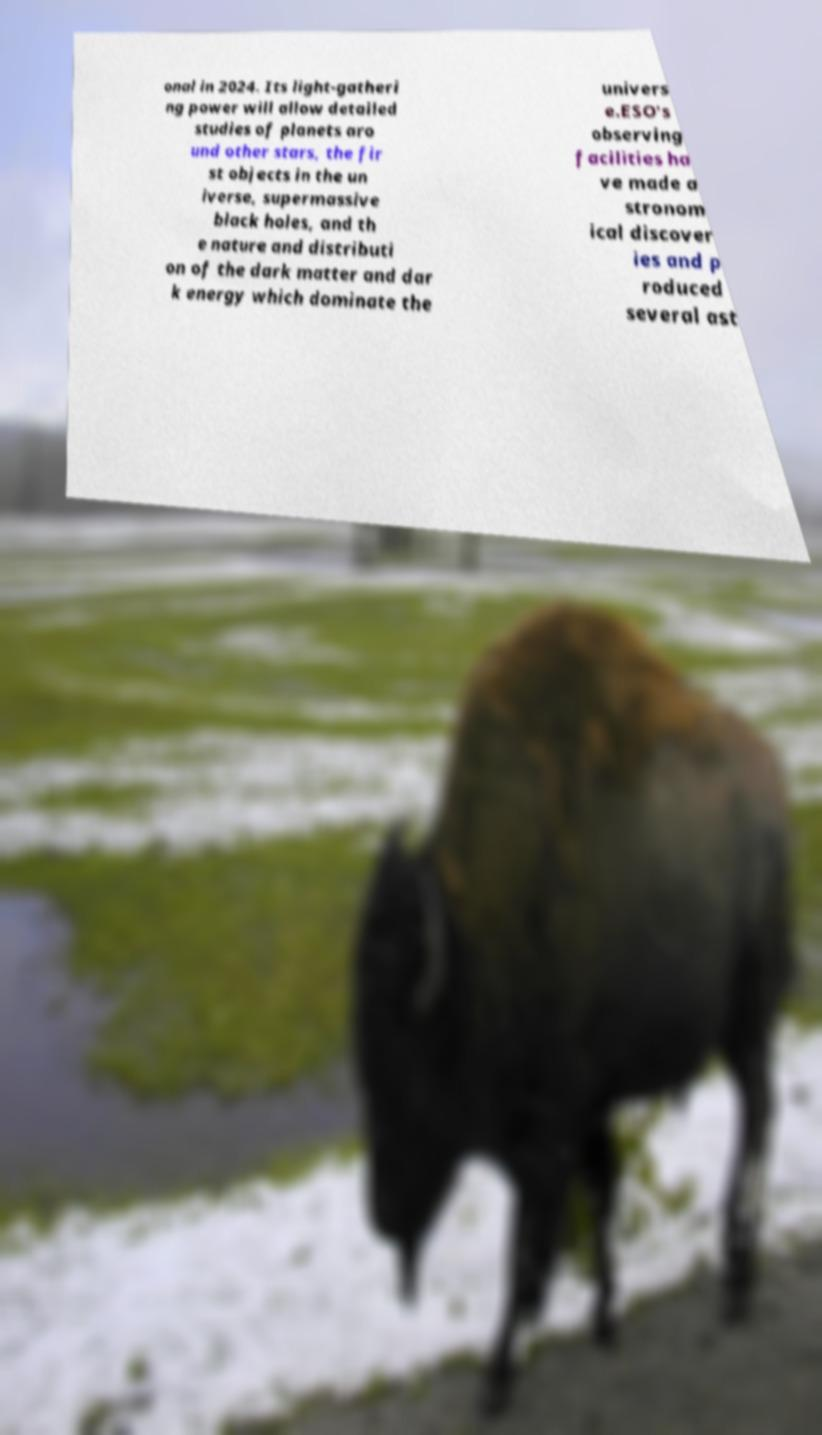Can you read and provide the text displayed in the image?This photo seems to have some interesting text. Can you extract and type it out for me? onal in 2024. Its light-gatheri ng power will allow detailed studies of planets aro und other stars, the fir st objects in the un iverse, supermassive black holes, and th e nature and distributi on of the dark matter and dar k energy which dominate the univers e.ESO's observing facilities ha ve made a stronom ical discover ies and p roduced several ast 